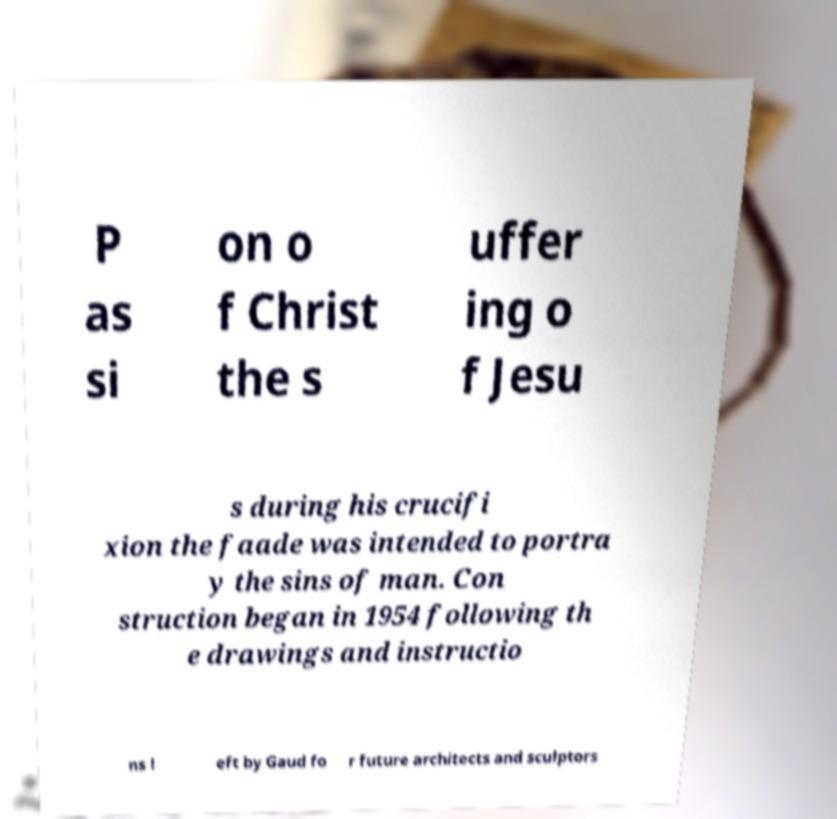There's text embedded in this image that I need extracted. Can you transcribe it verbatim? P as si on o f Christ the s uffer ing o f Jesu s during his crucifi xion the faade was intended to portra y the sins of man. Con struction began in 1954 following th e drawings and instructio ns l eft by Gaud fo r future architects and sculptors 